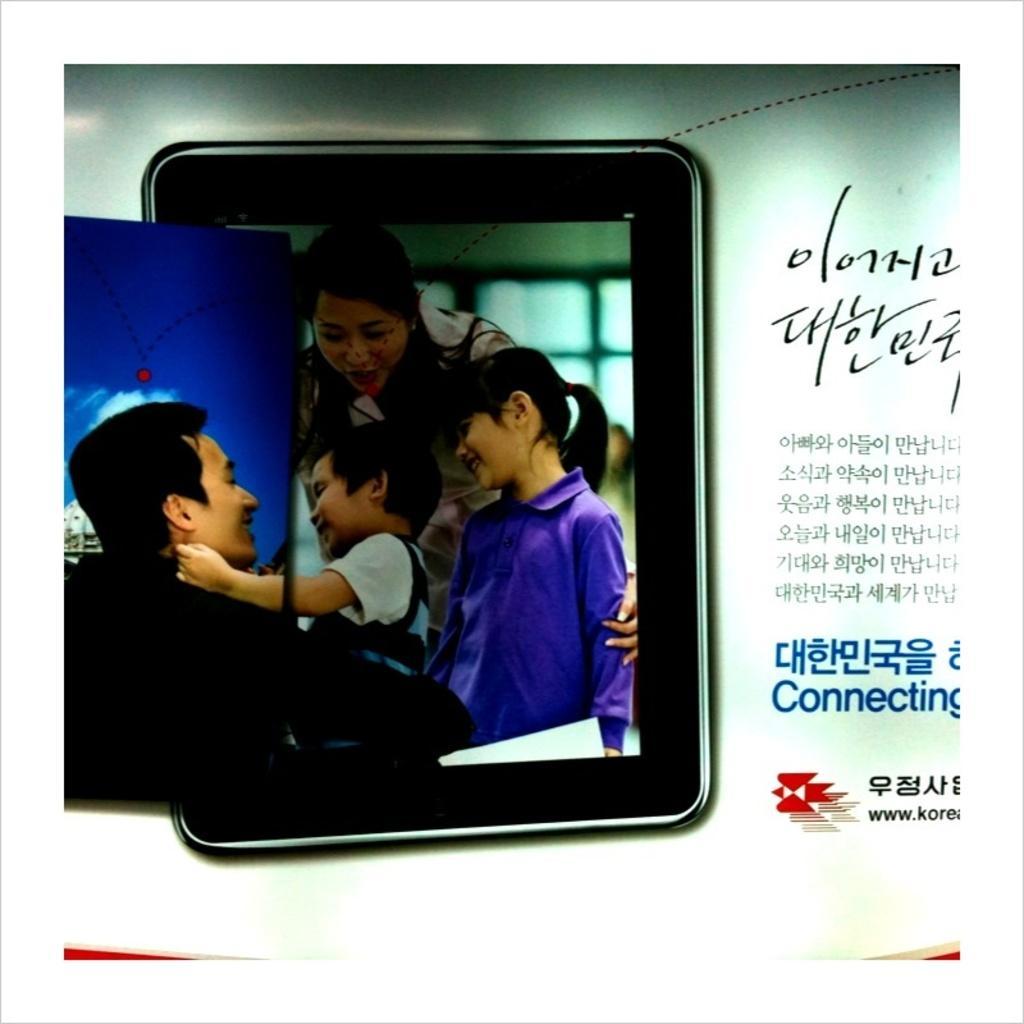In one or two sentences, can you explain what this image depicts? It is a poster. In this image, we can see few people are smiling. Right side of the image, we can see some text. 